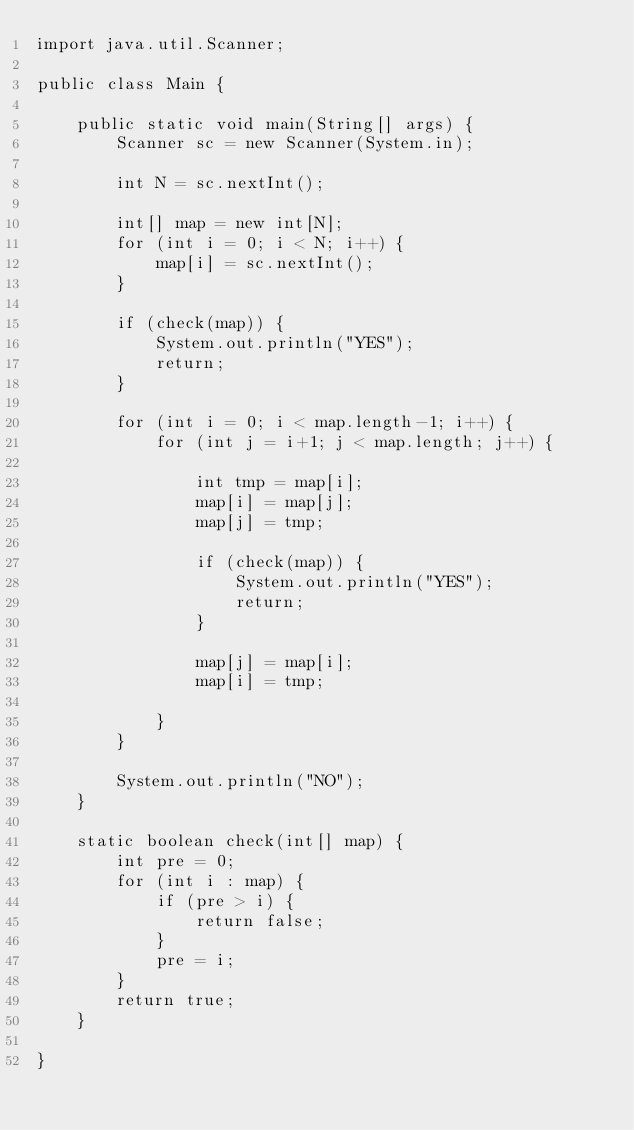Convert code to text. <code><loc_0><loc_0><loc_500><loc_500><_Java_>import java.util.Scanner;

public class Main {

	public static void main(String[] args) {
		Scanner sc = new Scanner(System.in);
		
		int N = sc.nextInt();
		
		int[] map = new int[N];
		for (int i = 0; i < N; i++) {
			map[i] = sc.nextInt();
		}
		
		if (check(map)) {
			System.out.println("YES");
			return;
		}
		
		for (int i = 0; i < map.length-1; i++) {
			for (int j = i+1; j < map.length; j++) {
				
				int tmp = map[i];
				map[i] = map[j];
				map[j] = tmp;
				
				if (check(map)) {
					System.out.println("YES");
					return;
				}
				
				map[j] = map[i];
				map[i] = tmp;
				
			}
		}
	
		System.out.println("NO");
	}
	
	static boolean check(int[] map) {
		int pre = 0;
		for (int i : map) {
			if (pre > i) {
				return false;
			}
			pre = i;
		}
		return true;
	}
	
}

</code> 